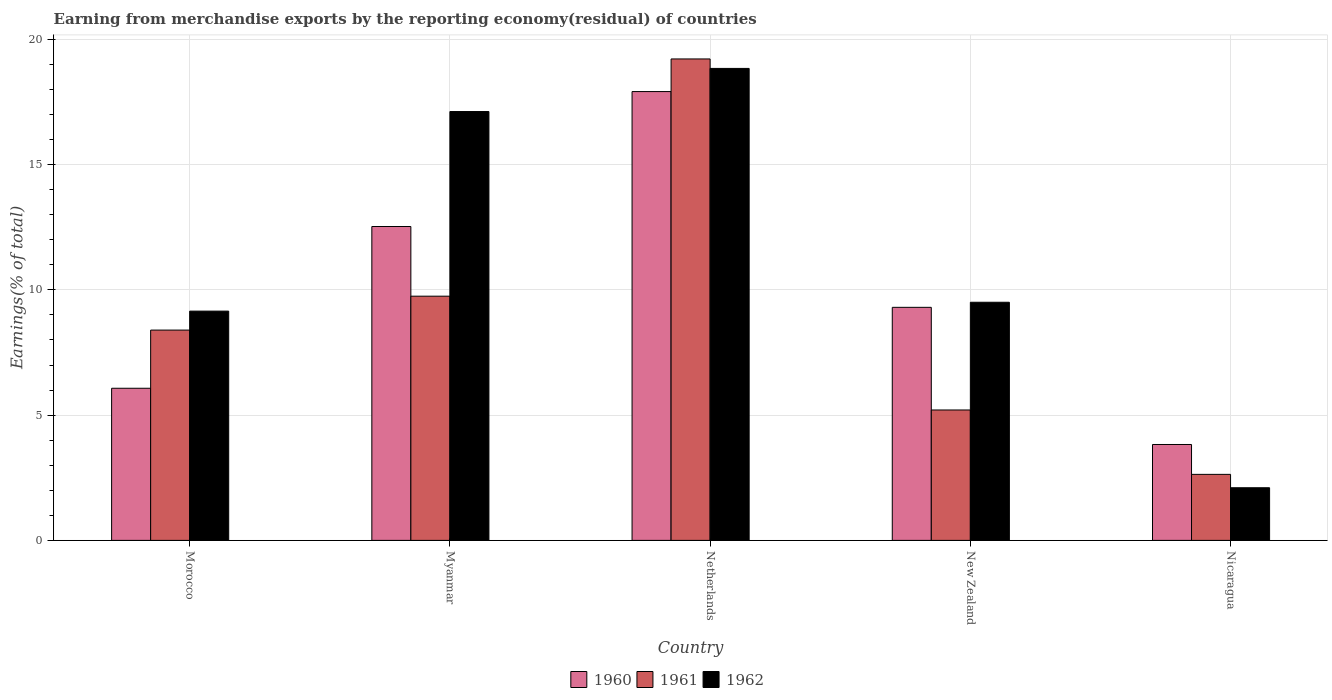How many bars are there on the 4th tick from the left?
Make the answer very short. 3. What is the label of the 1st group of bars from the left?
Keep it short and to the point. Morocco. In how many cases, is the number of bars for a given country not equal to the number of legend labels?
Offer a very short reply. 0. What is the percentage of amount earned from merchandise exports in 1961 in Myanmar?
Provide a succinct answer. 9.75. Across all countries, what is the maximum percentage of amount earned from merchandise exports in 1962?
Your answer should be very brief. 18.84. Across all countries, what is the minimum percentage of amount earned from merchandise exports in 1961?
Ensure brevity in your answer.  2.64. In which country was the percentage of amount earned from merchandise exports in 1961 maximum?
Make the answer very short. Netherlands. In which country was the percentage of amount earned from merchandise exports in 1962 minimum?
Offer a terse response. Nicaragua. What is the total percentage of amount earned from merchandise exports in 1960 in the graph?
Offer a very short reply. 49.65. What is the difference between the percentage of amount earned from merchandise exports in 1961 in Morocco and that in Netherlands?
Offer a very short reply. -10.82. What is the difference between the percentage of amount earned from merchandise exports in 1960 in Netherlands and the percentage of amount earned from merchandise exports in 1961 in Morocco?
Your response must be concise. 9.52. What is the average percentage of amount earned from merchandise exports in 1960 per country?
Make the answer very short. 9.93. What is the difference between the percentage of amount earned from merchandise exports of/in 1962 and percentage of amount earned from merchandise exports of/in 1960 in Nicaragua?
Provide a short and direct response. -1.73. What is the ratio of the percentage of amount earned from merchandise exports in 1961 in Myanmar to that in New Zealand?
Ensure brevity in your answer.  1.87. Is the percentage of amount earned from merchandise exports in 1960 in Myanmar less than that in Nicaragua?
Provide a succinct answer. No. Is the difference between the percentage of amount earned from merchandise exports in 1962 in Morocco and Netherlands greater than the difference between the percentage of amount earned from merchandise exports in 1960 in Morocco and Netherlands?
Make the answer very short. Yes. What is the difference between the highest and the second highest percentage of amount earned from merchandise exports in 1962?
Offer a very short reply. -1.72. What is the difference between the highest and the lowest percentage of amount earned from merchandise exports in 1962?
Make the answer very short. 16.74. Is the sum of the percentage of amount earned from merchandise exports in 1960 in Netherlands and Nicaragua greater than the maximum percentage of amount earned from merchandise exports in 1962 across all countries?
Ensure brevity in your answer.  Yes. What does the 1st bar from the left in Nicaragua represents?
Make the answer very short. 1960. Is it the case that in every country, the sum of the percentage of amount earned from merchandise exports in 1960 and percentage of amount earned from merchandise exports in 1961 is greater than the percentage of amount earned from merchandise exports in 1962?
Keep it short and to the point. Yes. Are all the bars in the graph horizontal?
Give a very brief answer. No. What is the difference between two consecutive major ticks on the Y-axis?
Your answer should be very brief. 5. Does the graph contain any zero values?
Your answer should be very brief. No. How many legend labels are there?
Offer a very short reply. 3. How are the legend labels stacked?
Offer a terse response. Horizontal. What is the title of the graph?
Provide a succinct answer. Earning from merchandise exports by the reporting economy(residual) of countries. Does "1960" appear as one of the legend labels in the graph?
Make the answer very short. Yes. What is the label or title of the X-axis?
Keep it short and to the point. Country. What is the label or title of the Y-axis?
Make the answer very short. Earnings(% of total). What is the Earnings(% of total) of 1960 in Morocco?
Provide a short and direct response. 6.07. What is the Earnings(% of total) in 1961 in Morocco?
Make the answer very short. 8.39. What is the Earnings(% of total) of 1962 in Morocco?
Give a very brief answer. 9.15. What is the Earnings(% of total) of 1960 in Myanmar?
Offer a terse response. 12.53. What is the Earnings(% of total) in 1961 in Myanmar?
Offer a very short reply. 9.75. What is the Earnings(% of total) of 1962 in Myanmar?
Provide a short and direct response. 17.12. What is the Earnings(% of total) in 1960 in Netherlands?
Your answer should be compact. 17.91. What is the Earnings(% of total) of 1961 in Netherlands?
Provide a succinct answer. 19.22. What is the Earnings(% of total) in 1962 in Netherlands?
Keep it short and to the point. 18.84. What is the Earnings(% of total) of 1960 in New Zealand?
Offer a terse response. 9.3. What is the Earnings(% of total) in 1961 in New Zealand?
Your answer should be very brief. 5.21. What is the Earnings(% of total) of 1962 in New Zealand?
Offer a terse response. 9.51. What is the Earnings(% of total) in 1960 in Nicaragua?
Provide a succinct answer. 3.83. What is the Earnings(% of total) in 1961 in Nicaragua?
Offer a very short reply. 2.64. What is the Earnings(% of total) of 1962 in Nicaragua?
Ensure brevity in your answer.  2.1. Across all countries, what is the maximum Earnings(% of total) in 1960?
Make the answer very short. 17.91. Across all countries, what is the maximum Earnings(% of total) of 1961?
Make the answer very short. 19.22. Across all countries, what is the maximum Earnings(% of total) of 1962?
Make the answer very short. 18.84. Across all countries, what is the minimum Earnings(% of total) of 1960?
Provide a short and direct response. 3.83. Across all countries, what is the minimum Earnings(% of total) of 1961?
Offer a very short reply. 2.64. Across all countries, what is the minimum Earnings(% of total) of 1962?
Provide a short and direct response. 2.1. What is the total Earnings(% of total) in 1960 in the graph?
Offer a terse response. 49.65. What is the total Earnings(% of total) of 1961 in the graph?
Your answer should be compact. 45.2. What is the total Earnings(% of total) in 1962 in the graph?
Make the answer very short. 56.72. What is the difference between the Earnings(% of total) of 1960 in Morocco and that in Myanmar?
Make the answer very short. -6.46. What is the difference between the Earnings(% of total) of 1961 in Morocco and that in Myanmar?
Give a very brief answer. -1.35. What is the difference between the Earnings(% of total) in 1962 in Morocco and that in Myanmar?
Keep it short and to the point. -7.97. What is the difference between the Earnings(% of total) in 1960 in Morocco and that in Netherlands?
Keep it short and to the point. -11.84. What is the difference between the Earnings(% of total) in 1961 in Morocco and that in Netherlands?
Your answer should be very brief. -10.82. What is the difference between the Earnings(% of total) in 1962 in Morocco and that in Netherlands?
Your response must be concise. -9.69. What is the difference between the Earnings(% of total) in 1960 in Morocco and that in New Zealand?
Give a very brief answer. -3.23. What is the difference between the Earnings(% of total) of 1961 in Morocco and that in New Zealand?
Provide a succinct answer. 3.19. What is the difference between the Earnings(% of total) in 1962 in Morocco and that in New Zealand?
Provide a succinct answer. -0.35. What is the difference between the Earnings(% of total) of 1960 in Morocco and that in Nicaragua?
Your answer should be very brief. 2.24. What is the difference between the Earnings(% of total) in 1961 in Morocco and that in Nicaragua?
Your answer should be compact. 5.76. What is the difference between the Earnings(% of total) in 1962 in Morocco and that in Nicaragua?
Provide a short and direct response. 7.05. What is the difference between the Earnings(% of total) of 1960 in Myanmar and that in Netherlands?
Your answer should be compact. -5.39. What is the difference between the Earnings(% of total) in 1961 in Myanmar and that in Netherlands?
Your answer should be very brief. -9.47. What is the difference between the Earnings(% of total) of 1962 in Myanmar and that in Netherlands?
Provide a short and direct response. -1.72. What is the difference between the Earnings(% of total) of 1960 in Myanmar and that in New Zealand?
Your answer should be compact. 3.23. What is the difference between the Earnings(% of total) of 1961 in Myanmar and that in New Zealand?
Keep it short and to the point. 4.54. What is the difference between the Earnings(% of total) of 1962 in Myanmar and that in New Zealand?
Your answer should be very brief. 7.61. What is the difference between the Earnings(% of total) in 1960 in Myanmar and that in Nicaragua?
Your response must be concise. 8.7. What is the difference between the Earnings(% of total) of 1961 in Myanmar and that in Nicaragua?
Your answer should be very brief. 7.11. What is the difference between the Earnings(% of total) of 1962 in Myanmar and that in Nicaragua?
Offer a terse response. 15.02. What is the difference between the Earnings(% of total) in 1960 in Netherlands and that in New Zealand?
Give a very brief answer. 8.61. What is the difference between the Earnings(% of total) in 1961 in Netherlands and that in New Zealand?
Offer a very short reply. 14.01. What is the difference between the Earnings(% of total) in 1962 in Netherlands and that in New Zealand?
Make the answer very short. 9.33. What is the difference between the Earnings(% of total) of 1960 in Netherlands and that in Nicaragua?
Your response must be concise. 14.09. What is the difference between the Earnings(% of total) in 1961 in Netherlands and that in Nicaragua?
Make the answer very short. 16.58. What is the difference between the Earnings(% of total) of 1962 in Netherlands and that in Nicaragua?
Your answer should be very brief. 16.74. What is the difference between the Earnings(% of total) in 1960 in New Zealand and that in Nicaragua?
Offer a terse response. 5.48. What is the difference between the Earnings(% of total) of 1961 in New Zealand and that in Nicaragua?
Offer a terse response. 2.57. What is the difference between the Earnings(% of total) in 1962 in New Zealand and that in Nicaragua?
Ensure brevity in your answer.  7.4. What is the difference between the Earnings(% of total) of 1960 in Morocco and the Earnings(% of total) of 1961 in Myanmar?
Give a very brief answer. -3.68. What is the difference between the Earnings(% of total) of 1960 in Morocco and the Earnings(% of total) of 1962 in Myanmar?
Provide a succinct answer. -11.05. What is the difference between the Earnings(% of total) in 1961 in Morocco and the Earnings(% of total) in 1962 in Myanmar?
Offer a terse response. -8.72. What is the difference between the Earnings(% of total) in 1960 in Morocco and the Earnings(% of total) in 1961 in Netherlands?
Keep it short and to the point. -13.14. What is the difference between the Earnings(% of total) in 1960 in Morocco and the Earnings(% of total) in 1962 in Netherlands?
Offer a very short reply. -12.77. What is the difference between the Earnings(% of total) of 1961 in Morocco and the Earnings(% of total) of 1962 in Netherlands?
Offer a terse response. -10.45. What is the difference between the Earnings(% of total) in 1960 in Morocco and the Earnings(% of total) in 1961 in New Zealand?
Your answer should be compact. 0.87. What is the difference between the Earnings(% of total) in 1960 in Morocco and the Earnings(% of total) in 1962 in New Zealand?
Provide a short and direct response. -3.43. What is the difference between the Earnings(% of total) of 1961 in Morocco and the Earnings(% of total) of 1962 in New Zealand?
Provide a succinct answer. -1.11. What is the difference between the Earnings(% of total) in 1960 in Morocco and the Earnings(% of total) in 1961 in Nicaragua?
Make the answer very short. 3.44. What is the difference between the Earnings(% of total) in 1960 in Morocco and the Earnings(% of total) in 1962 in Nicaragua?
Ensure brevity in your answer.  3.97. What is the difference between the Earnings(% of total) of 1961 in Morocco and the Earnings(% of total) of 1962 in Nicaragua?
Offer a very short reply. 6.29. What is the difference between the Earnings(% of total) of 1960 in Myanmar and the Earnings(% of total) of 1961 in Netherlands?
Your answer should be compact. -6.69. What is the difference between the Earnings(% of total) of 1960 in Myanmar and the Earnings(% of total) of 1962 in Netherlands?
Your answer should be compact. -6.31. What is the difference between the Earnings(% of total) of 1961 in Myanmar and the Earnings(% of total) of 1962 in Netherlands?
Your answer should be very brief. -9.09. What is the difference between the Earnings(% of total) in 1960 in Myanmar and the Earnings(% of total) in 1961 in New Zealand?
Offer a very short reply. 7.32. What is the difference between the Earnings(% of total) of 1960 in Myanmar and the Earnings(% of total) of 1962 in New Zealand?
Your answer should be compact. 3.02. What is the difference between the Earnings(% of total) in 1961 in Myanmar and the Earnings(% of total) in 1962 in New Zealand?
Keep it short and to the point. 0.24. What is the difference between the Earnings(% of total) in 1960 in Myanmar and the Earnings(% of total) in 1961 in Nicaragua?
Ensure brevity in your answer.  9.89. What is the difference between the Earnings(% of total) of 1960 in Myanmar and the Earnings(% of total) of 1962 in Nicaragua?
Offer a very short reply. 10.43. What is the difference between the Earnings(% of total) in 1961 in Myanmar and the Earnings(% of total) in 1962 in Nicaragua?
Ensure brevity in your answer.  7.65. What is the difference between the Earnings(% of total) in 1960 in Netherlands and the Earnings(% of total) in 1961 in New Zealand?
Your response must be concise. 12.71. What is the difference between the Earnings(% of total) in 1960 in Netherlands and the Earnings(% of total) in 1962 in New Zealand?
Ensure brevity in your answer.  8.41. What is the difference between the Earnings(% of total) in 1961 in Netherlands and the Earnings(% of total) in 1962 in New Zealand?
Offer a very short reply. 9.71. What is the difference between the Earnings(% of total) of 1960 in Netherlands and the Earnings(% of total) of 1961 in Nicaragua?
Your answer should be very brief. 15.28. What is the difference between the Earnings(% of total) of 1960 in Netherlands and the Earnings(% of total) of 1962 in Nicaragua?
Your answer should be compact. 15.81. What is the difference between the Earnings(% of total) of 1961 in Netherlands and the Earnings(% of total) of 1962 in Nicaragua?
Make the answer very short. 17.12. What is the difference between the Earnings(% of total) of 1960 in New Zealand and the Earnings(% of total) of 1961 in Nicaragua?
Your response must be concise. 6.67. What is the difference between the Earnings(% of total) in 1960 in New Zealand and the Earnings(% of total) in 1962 in Nicaragua?
Your answer should be very brief. 7.2. What is the difference between the Earnings(% of total) in 1961 in New Zealand and the Earnings(% of total) in 1962 in Nicaragua?
Give a very brief answer. 3.1. What is the average Earnings(% of total) of 1960 per country?
Offer a terse response. 9.93. What is the average Earnings(% of total) of 1961 per country?
Provide a short and direct response. 9.04. What is the average Earnings(% of total) in 1962 per country?
Offer a terse response. 11.34. What is the difference between the Earnings(% of total) of 1960 and Earnings(% of total) of 1961 in Morocco?
Your response must be concise. -2.32. What is the difference between the Earnings(% of total) in 1960 and Earnings(% of total) in 1962 in Morocco?
Give a very brief answer. -3.08. What is the difference between the Earnings(% of total) of 1961 and Earnings(% of total) of 1962 in Morocco?
Offer a terse response. -0.76. What is the difference between the Earnings(% of total) in 1960 and Earnings(% of total) in 1961 in Myanmar?
Offer a very short reply. 2.78. What is the difference between the Earnings(% of total) of 1960 and Earnings(% of total) of 1962 in Myanmar?
Your answer should be compact. -4.59. What is the difference between the Earnings(% of total) in 1961 and Earnings(% of total) in 1962 in Myanmar?
Give a very brief answer. -7.37. What is the difference between the Earnings(% of total) in 1960 and Earnings(% of total) in 1961 in Netherlands?
Make the answer very short. -1.3. What is the difference between the Earnings(% of total) of 1960 and Earnings(% of total) of 1962 in Netherlands?
Provide a succinct answer. -0.92. What is the difference between the Earnings(% of total) of 1961 and Earnings(% of total) of 1962 in Netherlands?
Offer a very short reply. 0.38. What is the difference between the Earnings(% of total) of 1960 and Earnings(% of total) of 1961 in New Zealand?
Offer a terse response. 4.1. What is the difference between the Earnings(% of total) of 1960 and Earnings(% of total) of 1962 in New Zealand?
Make the answer very short. -0.2. What is the difference between the Earnings(% of total) of 1961 and Earnings(% of total) of 1962 in New Zealand?
Offer a very short reply. -4.3. What is the difference between the Earnings(% of total) in 1960 and Earnings(% of total) in 1961 in Nicaragua?
Provide a succinct answer. 1.19. What is the difference between the Earnings(% of total) of 1960 and Earnings(% of total) of 1962 in Nicaragua?
Provide a succinct answer. 1.73. What is the difference between the Earnings(% of total) of 1961 and Earnings(% of total) of 1962 in Nicaragua?
Provide a short and direct response. 0.53. What is the ratio of the Earnings(% of total) in 1960 in Morocco to that in Myanmar?
Your response must be concise. 0.48. What is the ratio of the Earnings(% of total) of 1961 in Morocco to that in Myanmar?
Ensure brevity in your answer.  0.86. What is the ratio of the Earnings(% of total) in 1962 in Morocco to that in Myanmar?
Offer a terse response. 0.53. What is the ratio of the Earnings(% of total) in 1960 in Morocco to that in Netherlands?
Ensure brevity in your answer.  0.34. What is the ratio of the Earnings(% of total) of 1961 in Morocco to that in Netherlands?
Your response must be concise. 0.44. What is the ratio of the Earnings(% of total) of 1962 in Morocco to that in Netherlands?
Offer a terse response. 0.49. What is the ratio of the Earnings(% of total) in 1960 in Morocco to that in New Zealand?
Keep it short and to the point. 0.65. What is the ratio of the Earnings(% of total) in 1961 in Morocco to that in New Zealand?
Keep it short and to the point. 1.61. What is the ratio of the Earnings(% of total) in 1962 in Morocco to that in New Zealand?
Make the answer very short. 0.96. What is the ratio of the Earnings(% of total) in 1960 in Morocco to that in Nicaragua?
Provide a succinct answer. 1.59. What is the ratio of the Earnings(% of total) of 1961 in Morocco to that in Nicaragua?
Give a very brief answer. 3.19. What is the ratio of the Earnings(% of total) in 1962 in Morocco to that in Nicaragua?
Keep it short and to the point. 4.35. What is the ratio of the Earnings(% of total) in 1960 in Myanmar to that in Netherlands?
Your answer should be compact. 0.7. What is the ratio of the Earnings(% of total) in 1961 in Myanmar to that in Netherlands?
Your answer should be very brief. 0.51. What is the ratio of the Earnings(% of total) in 1962 in Myanmar to that in Netherlands?
Your answer should be very brief. 0.91. What is the ratio of the Earnings(% of total) of 1960 in Myanmar to that in New Zealand?
Give a very brief answer. 1.35. What is the ratio of the Earnings(% of total) in 1961 in Myanmar to that in New Zealand?
Give a very brief answer. 1.87. What is the ratio of the Earnings(% of total) in 1962 in Myanmar to that in New Zealand?
Your response must be concise. 1.8. What is the ratio of the Earnings(% of total) of 1960 in Myanmar to that in Nicaragua?
Provide a succinct answer. 3.27. What is the ratio of the Earnings(% of total) in 1961 in Myanmar to that in Nicaragua?
Your response must be concise. 3.7. What is the ratio of the Earnings(% of total) in 1962 in Myanmar to that in Nicaragua?
Ensure brevity in your answer.  8.14. What is the ratio of the Earnings(% of total) of 1960 in Netherlands to that in New Zealand?
Provide a short and direct response. 1.93. What is the ratio of the Earnings(% of total) of 1961 in Netherlands to that in New Zealand?
Offer a terse response. 3.69. What is the ratio of the Earnings(% of total) of 1962 in Netherlands to that in New Zealand?
Your answer should be compact. 1.98. What is the ratio of the Earnings(% of total) of 1960 in Netherlands to that in Nicaragua?
Make the answer very short. 4.68. What is the ratio of the Earnings(% of total) in 1961 in Netherlands to that in Nicaragua?
Provide a short and direct response. 7.29. What is the ratio of the Earnings(% of total) of 1962 in Netherlands to that in Nicaragua?
Ensure brevity in your answer.  8.96. What is the ratio of the Earnings(% of total) in 1960 in New Zealand to that in Nicaragua?
Your response must be concise. 2.43. What is the ratio of the Earnings(% of total) in 1961 in New Zealand to that in Nicaragua?
Offer a terse response. 1.98. What is the ratio of the Earnings(% of total) in 1962 in New Zealand to that in Nicaragua?
Make the answer very short. 4.52. What is the difference between the highest and the second highest Earnings(% of total) of 1960?
Your response must be concise. 5.39. What is the difference between the highest and the second highest Earnings(% of total) in 1961?
Ensure brevity in your answer.  9.47. What is the difference between the highest and the second highest Earnings(% of total) in 1962?
Provide a succinct answer. 1.72. What is the difference between the highest and the lowest Earnings(% of total) of 1960?
Ensure brevity in your answer.  14.09. What is the difference between the highest and the lowest Earnings(% of total) of 1961?
Offer a very short reply. 16.58. What is the difference between the highest and the lowest Earnings(% of total) in 1962?
Give a very brief answer. 16.74. 